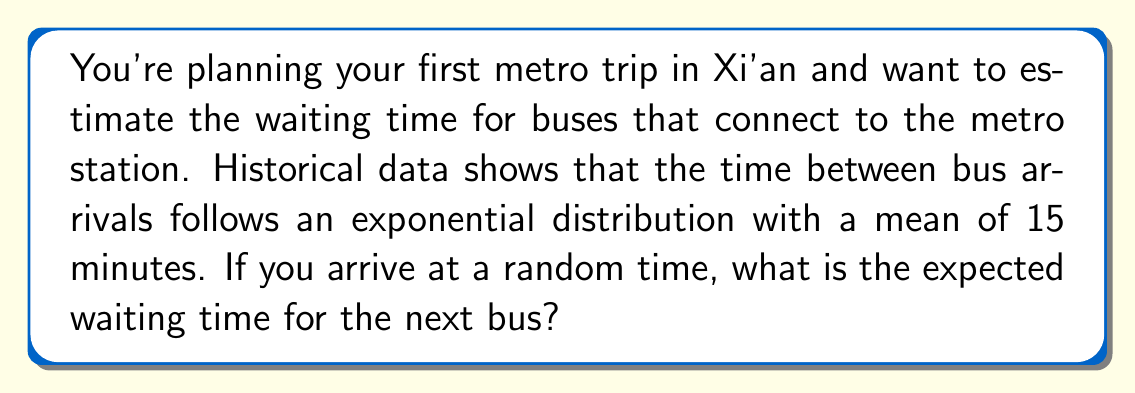Teach me how to tackle this problem. Let's approach this step-by-step using renewal process theory:

1) In a renewal process where inter-arrival times follow an exponential distribution, the process has the memoryless property. This means that regardless of when you arrive, the waiting time for the next arrival is independent of how long it's been since the last arrival.

2) For an exponential distribution with mean $\mu$, the probability density function is:

   $$f(t) = \frac{1}{\mu}e^{-t/\mu}$$

3) In renewal theory, there's a result known as the "inspection paradox" or "waiting time paradox". It states that for a renewal process with inter-arrival times having mean $\mu$ and variance $\sigma^2$, the expected waiting time for someone arriving at a random time is:

   $$E[W] = \frac{\mu^2 + \sigma^2}{2\mu}$$

4) For an exponential distribution, the variance is equal to the square of the mean. So, $\sigma^2 = \mu^2 = 15^2 = 225$.

5) Plugging these values into the formula:

   $$E[W] = \frac{15^2 + 225}{2(15)} = \frac{450}{30} = 15$$

6) Therefore, the expected waiting time is 15 minutes, which is the same as the mean inter-arrival time.

This result might seem counterintuitive at first, but it's a well-known property of exponential distributions in renewal processes. The memoryless property implies that no matter when you arrive, you always expect to wait for one full inter-arrival period on average.
Answer: 15 minutes 